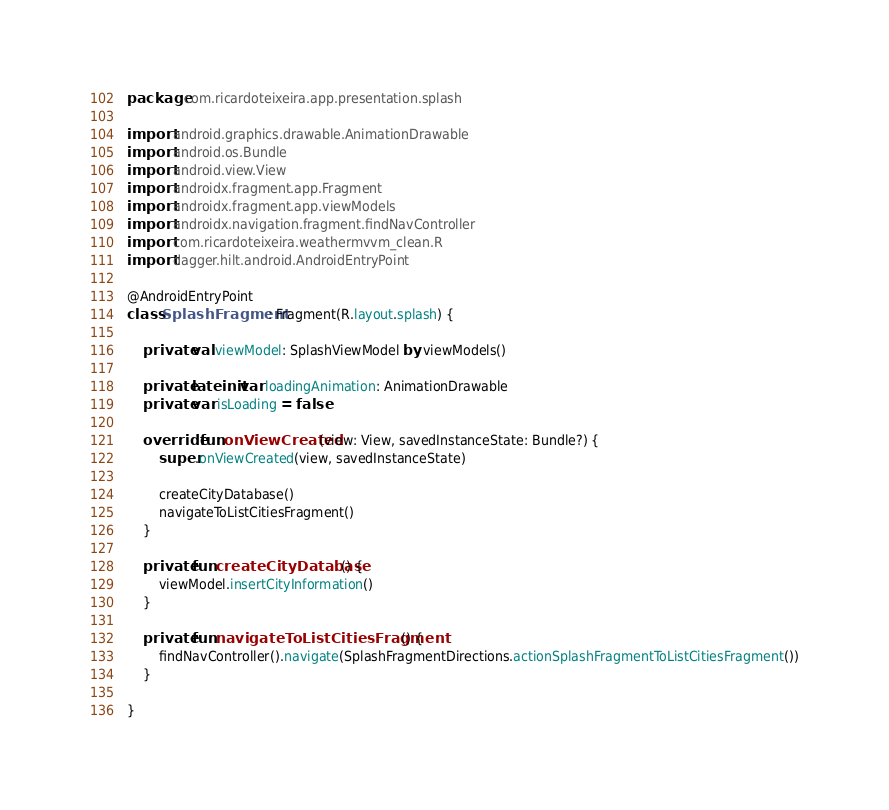<code> <loc_0><loc_0><loc_500><loc_500><_Kotlin_>package com.ricardoteixeira.app.presentation.splash

import android.graphics.drawable.AnimationDrawable
import android.os.Bundle
import android.view.View
import androidx.fragment.app.Fragment
import androidx.fragment.app.viewModels
import androidx.navigation.fragment.findNavController
import com.ricardoteixeira.weathermvvm_clean.R
import dagger.hilt.android.AndroidEntryPoint

@AndroidEntryPoint
class SplashFragment : Fragment(R.layout.splash) {

    private val viewModel: SplashViewModel by viewModels()

    private lateinit var loadingAnimation: AnimationDrawable
    private var isLoading = false

    override fun onViewCreated(view: View, savedInstanceState: Bundle?) {
        super.onViewCreated(view, savedInstanceState)

        createCityDatabase()
        navigateToListCitiesFragment()
    }

    private fun createCityDatabase() {
        viewModel.insertCityInformation()
    }

    private fun navigateToListCitiesFragment() {
        findNavController().navigate(SplashFragmentDirections.actionSplashFragmentToListCitiesFragment())
    }

}</code> 